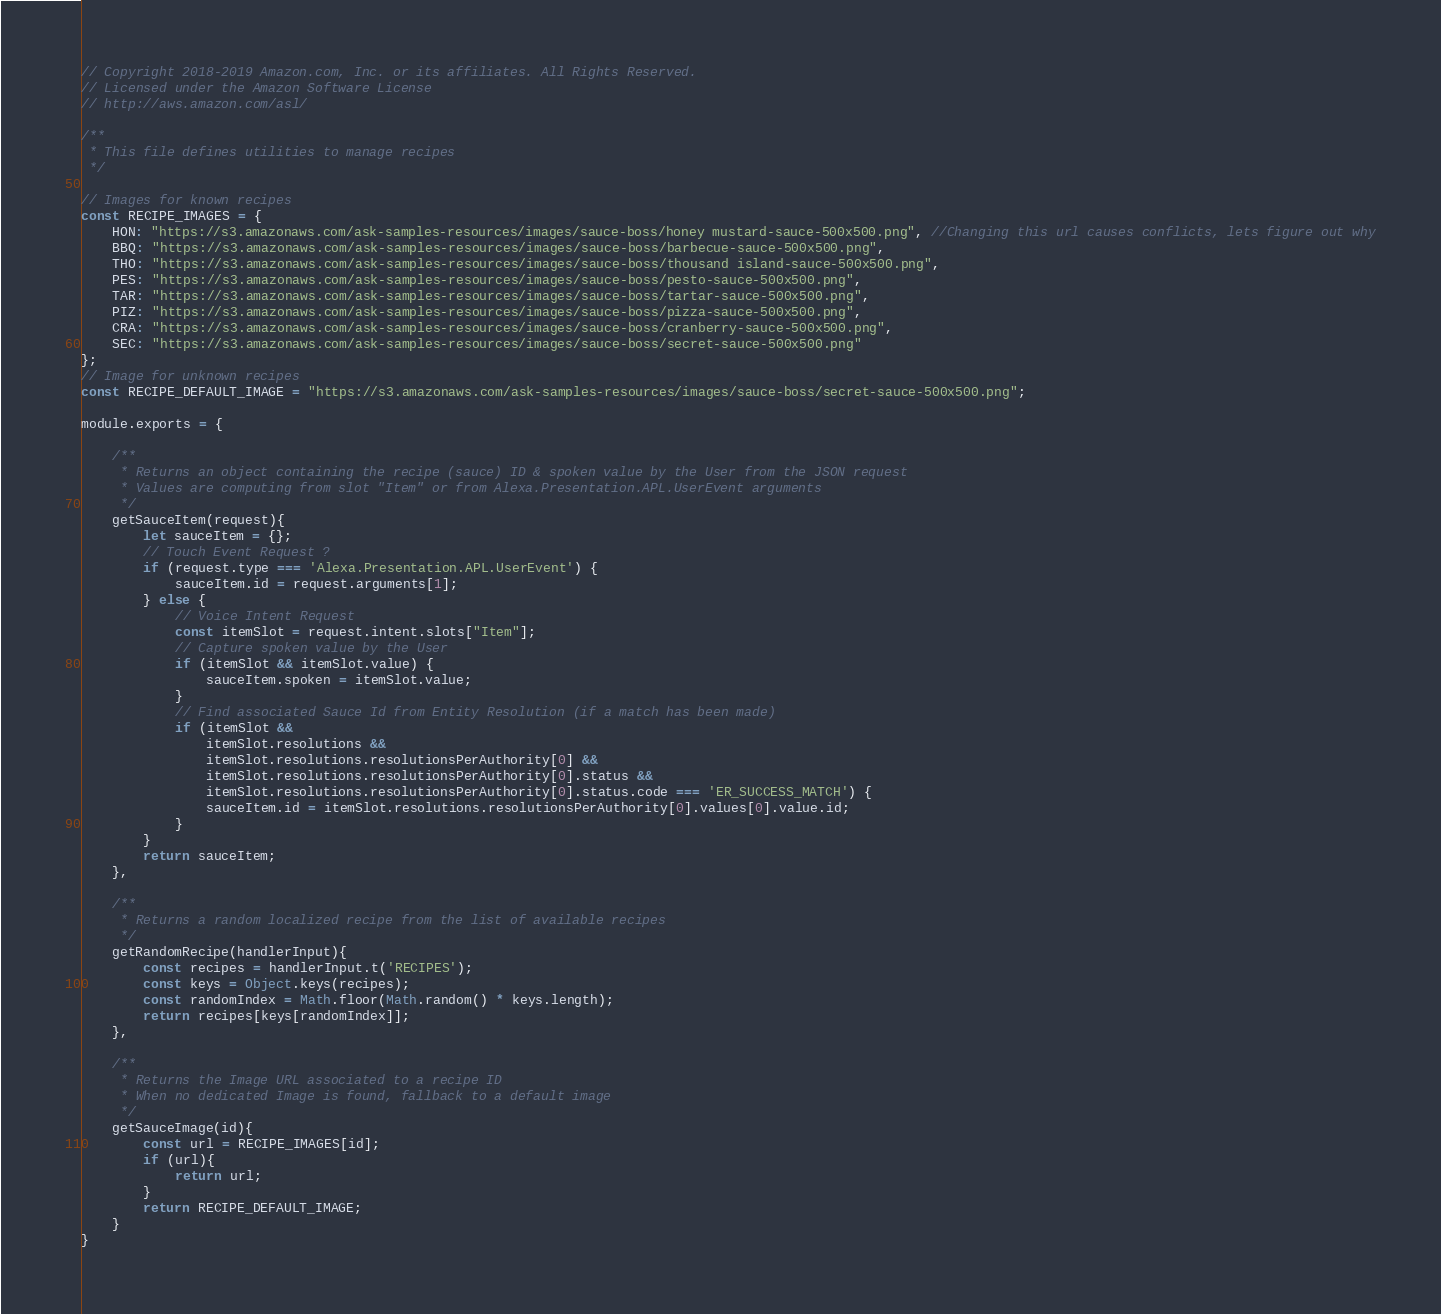<code> <loc_0><loc_0><loc_500><loc_500><_JavaScript_>// Copyright 2018-2019 Amazon.com, Inc. or its affiliates. All Rights Reserved.
// Licensed under the Amazon Software License
// http://aws.amazon.com/asl/

/**
 * This file defines utilities to manage recipes
 */

// Images for known recipes
const RECIPE_IMAGES = {
    HON: "https://s3.amazonaws.com/ask-samples-resources/images/sauce-boss/honey mustard-sauce-500x500.png", //Changing this url causes conflicts, lets figure out why
    BBQ: "https://s3.amazonaws.com/ask-samples-resources/images/sauce-boss/barbecue-sauce-500x500.png",
    THO: "https://s3.amazonaws.com/ask-samples-resources/images/sauce-boss/thousand island-sauce-500x500.png",
    PES: "https://s3.amazonaws.com/ask-samples-resources/images/sauce-boss/pesto-sauce-500x500.png",
    TAR: "https://s3.amazonaws.com/ask-samples-resources/images/sauce-boss/tartar-sauce-500x500.png",
    PIZ: "https://s3.amazonaws.com/ask-samples-resources/images/sauce-boss/pizza-sauce-500x500.png",
    CRA: "https://s3.amazonaws.com/ask-samples-resources/images/sauce-boss/cranberry-sauce-500x500.png",
    SEC: "https://s3.amazonaws.com/ask-samples-resources/images/sauce-boss/secret-sauce-500x500.png"
};
// Image for unknown recipes
const RECIPE_DEFAULT_IMAGE = "https://s3.amazonaws.com/ask-samples-resources/images/sauce-boss/secret-sauce-500x500.png";

module.exports = {

    /**
     * Returns an object containing the recipe (sauce) ID & spoken value by the User from the JSON request
     * Values are computing from slot "Item" or from Alexa.Presentation.APL.UserEvent arguments
     */
    getSauceItem(request){
        let sauceItem = {};
        // Touch Event Request ?
        if (request.type === 'Alexa.Presentation.APL.UserEvent') {
            sauceItem.id = request.arguments[1];
        } else {
            // Voice Intent Request
            const itemSlot = request.intent.slots["Item"];
            // Capture spoken value by the User
            if (itemSlot && itemSlot.value) {
                sauceItem.spoken = itemSlot.value;
            }
            // Find associated Sauce Id from Entity Resolution (if a match has been made)
            if (itemSlot &&
                itemSlot.resolutions &&
                itemSlot.resolutions.resolutionsPerAuthority[0] &&
                itemSlot.resolutions.resolutionsPerAuthority[0].status &&
                itemSlot.resolutions.resolutionsPerAuthority[0].status.code === 'ER_SUCCESS_MATCH') {
                sauceItem.id = itemSlot.resolutions.resolutionsPerAuthority[0].values[0].value.id;
            }
        }
        return sauceItem;
    },

    /**
     * Returns a random localized recipe from the list of available recipes
     */
    getRandomRecipe(handlerInput){
        const recipes = handlerInput.t('RECIPES');
        const keys = Object.keys(recipes);
        const randomIndex = Math.floor(Math.random() * keys.length);
        return recipes[keys[randomIndex]];
    },

    /**
     * Returns the Image URL associated to a recipe ID
     * When no dedicated Image is found, fallback to a default image 
     */
    getSauceImage(id){
        const url = RECIPE_IMAGES[id];
        if (url){
            return url;
        }
        return RECIPE_DEFAULT_IMAGE;
    }
}</code> 